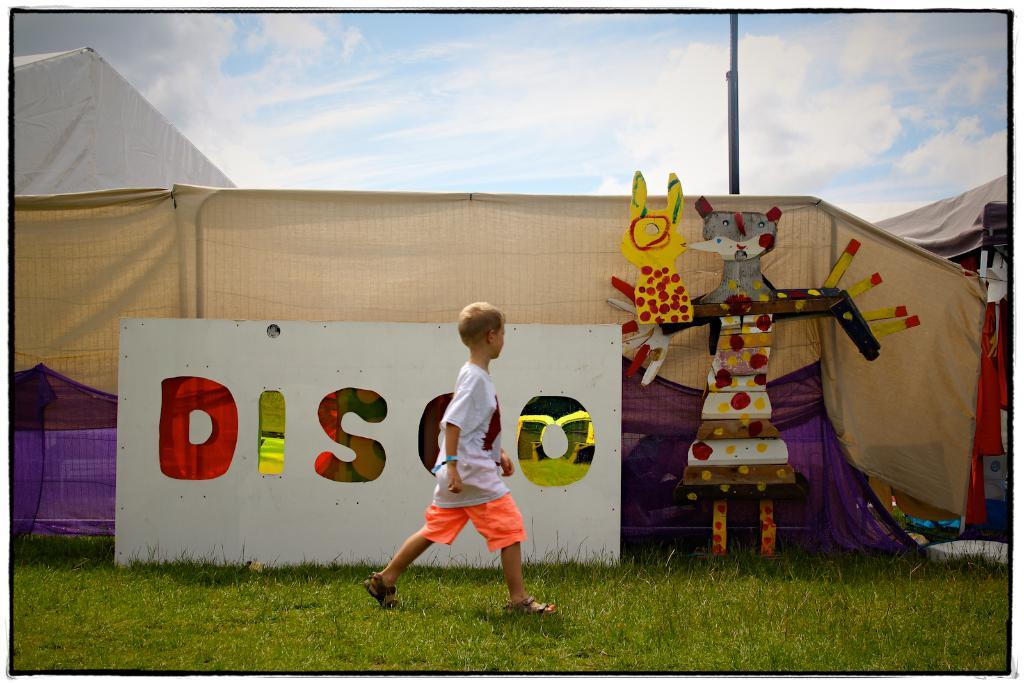<image>
Create a compact narrative representing the image presented. A boy walks in front of a sign that reads Disco in large letters. 